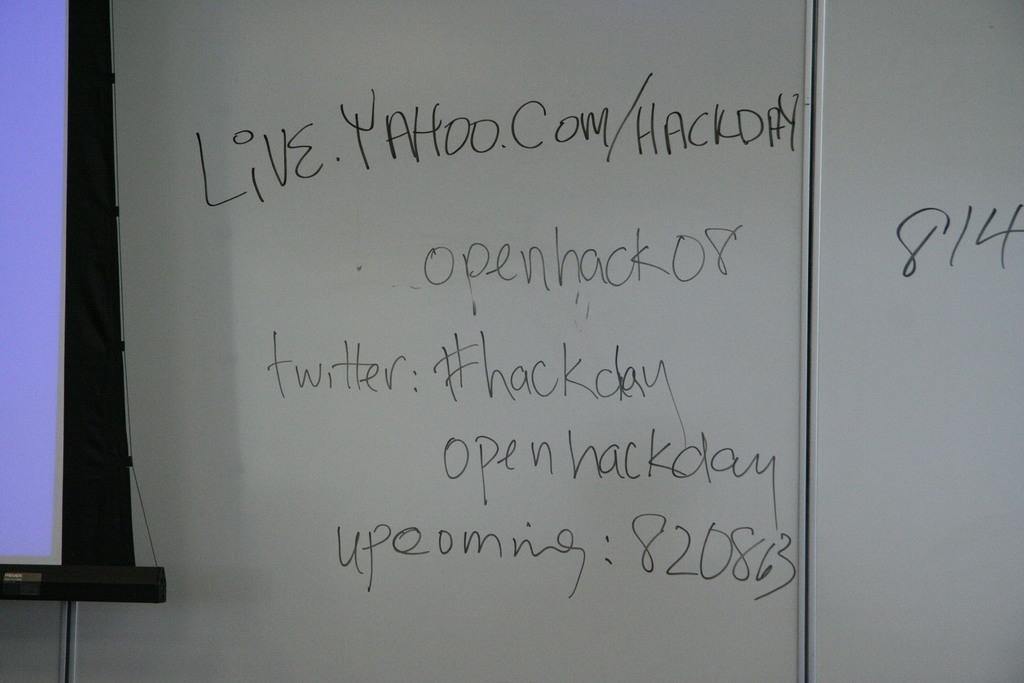<image>
Describe the image concisely. A white board has some urls and twitter hash tags written on it. 